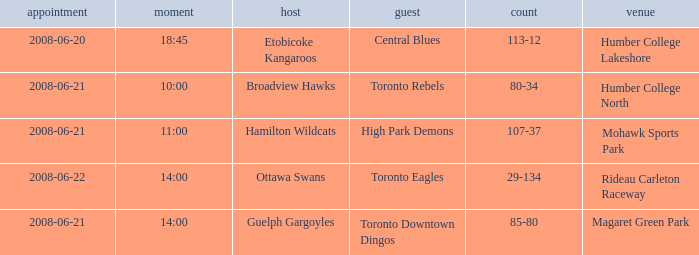What is the Date with a Home that is hamilton wildcats? 2008-06-21. 